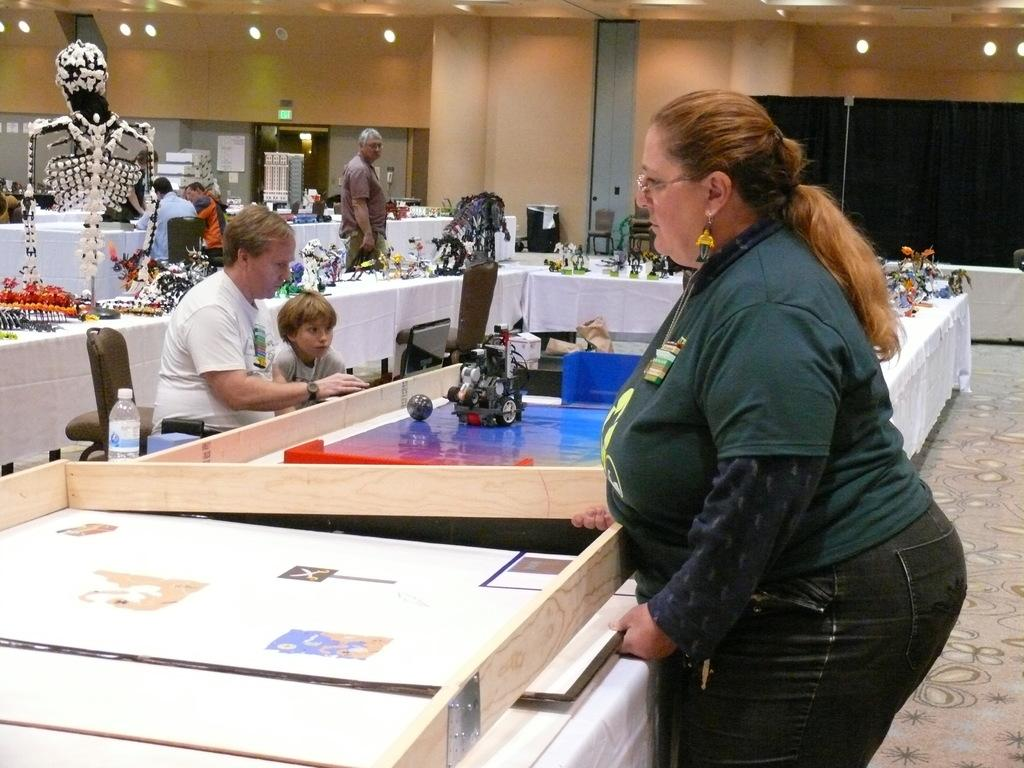Who is the main subject in the image? There is a lady standing in the center of the image. What can be seen in the background of the image? There is a wall in the background of the image. How many people are present in the image? There are persons standing in the image. What type of rifle is the lady holding in the image? There is no rifle present in the image; the lady is not holding any weapon. 